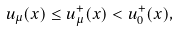Convert formula to latex. <formula><loc_0><loc_0><loc_500><loc_500>u _ { \mu } ( x ) \leq u ^ { + } _ { \mu } ( x ) < u ^ { + } _ { 0 } ( x ) ,</formula> 